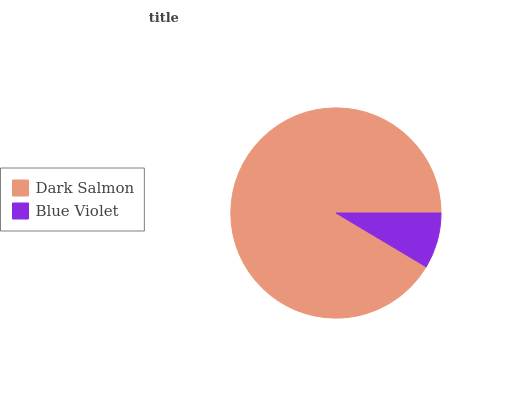Is Blue Violet the minimum?
Answer yes or no. Yes. Is Dark Salmon the maximum?
Answer yes or no. Yes. Is Blue Violet the maximum?
Answer yes or no. No. Is Dark Salmon greater than Blue Violet?
Answer yes or no. Yes. Is Blue Violet less than Dark Salmon?
Answer yes or no. Yes. Is Blue Violet greater than Dark Salmon?
Answer yes or no. No. Is Dark Salmon less than Blue Violet?
Answer yes or no. No. Is Dark Salmon the high median?
Answer yes or no. Yes. Is Blue Violet the low median?
Answer yes or no. Yes. Is Blue Violet the high median?
Answer yes or no. No. Is Dark Salmon the low median?
Answer yes or no. No. 